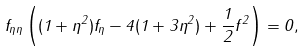Convert formula to latex. <formula><loc_0><loc_0><loc_500><loc_500>f _ { \eta \eta } \left ( ( 1 + \eta ^ { 2 } ) f _ { \eta } - 4 ( 1 + 3 \eta ^ { 2 } ) + \frac { 1 } { 2 } f ^ { 2 } \right ) = 0 ,</formula> 